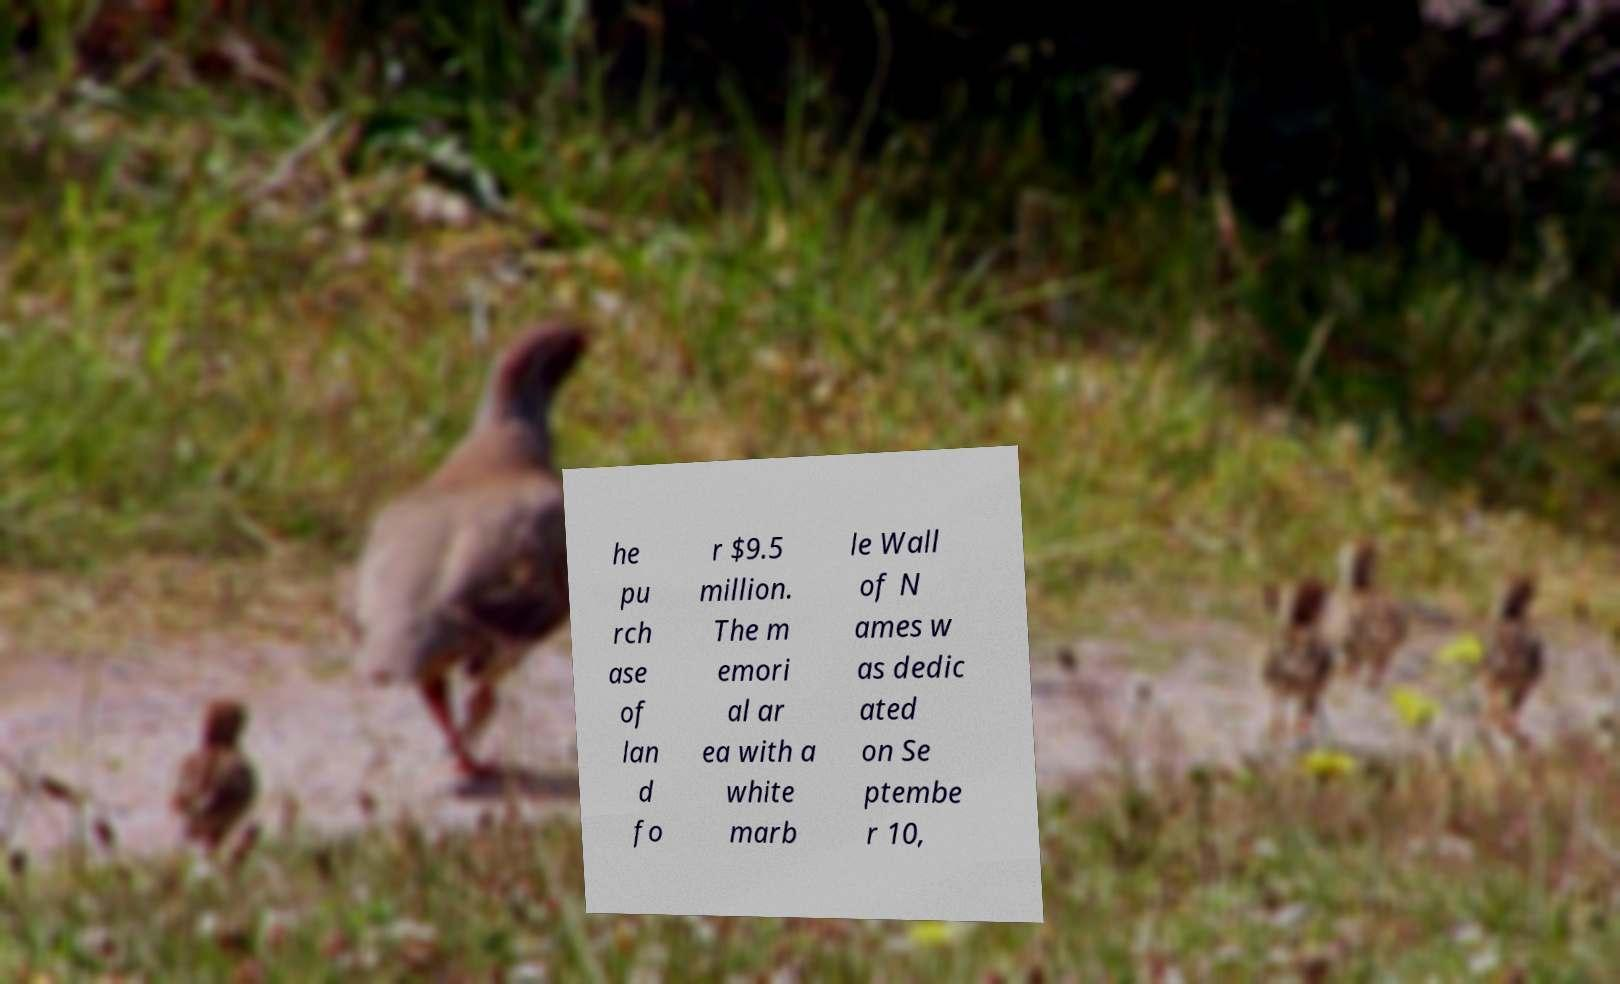For documentation purposes, I need the text within this image transcribed. Could you provide that? he pu rch ase of lan d fo r $9.5 million. The m emori al ar ea with a white marb le Wall of N ames w as dedic ated on Se ptembe r 10, 